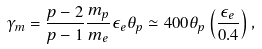<formula> <loc_0><loc_0><loc_500><loc_500>\gamma _ { m } = \frac { p - 2 } { p - 1 } \frac { m _ { p } } { m _ { e } } \epsilon _ { e } \theta _ { p } \simeq 4 0 0 \theta _ { p } \left ( \frac { \epsilon _ { e } } { 0 . 4 } \right ) ,</formula> 